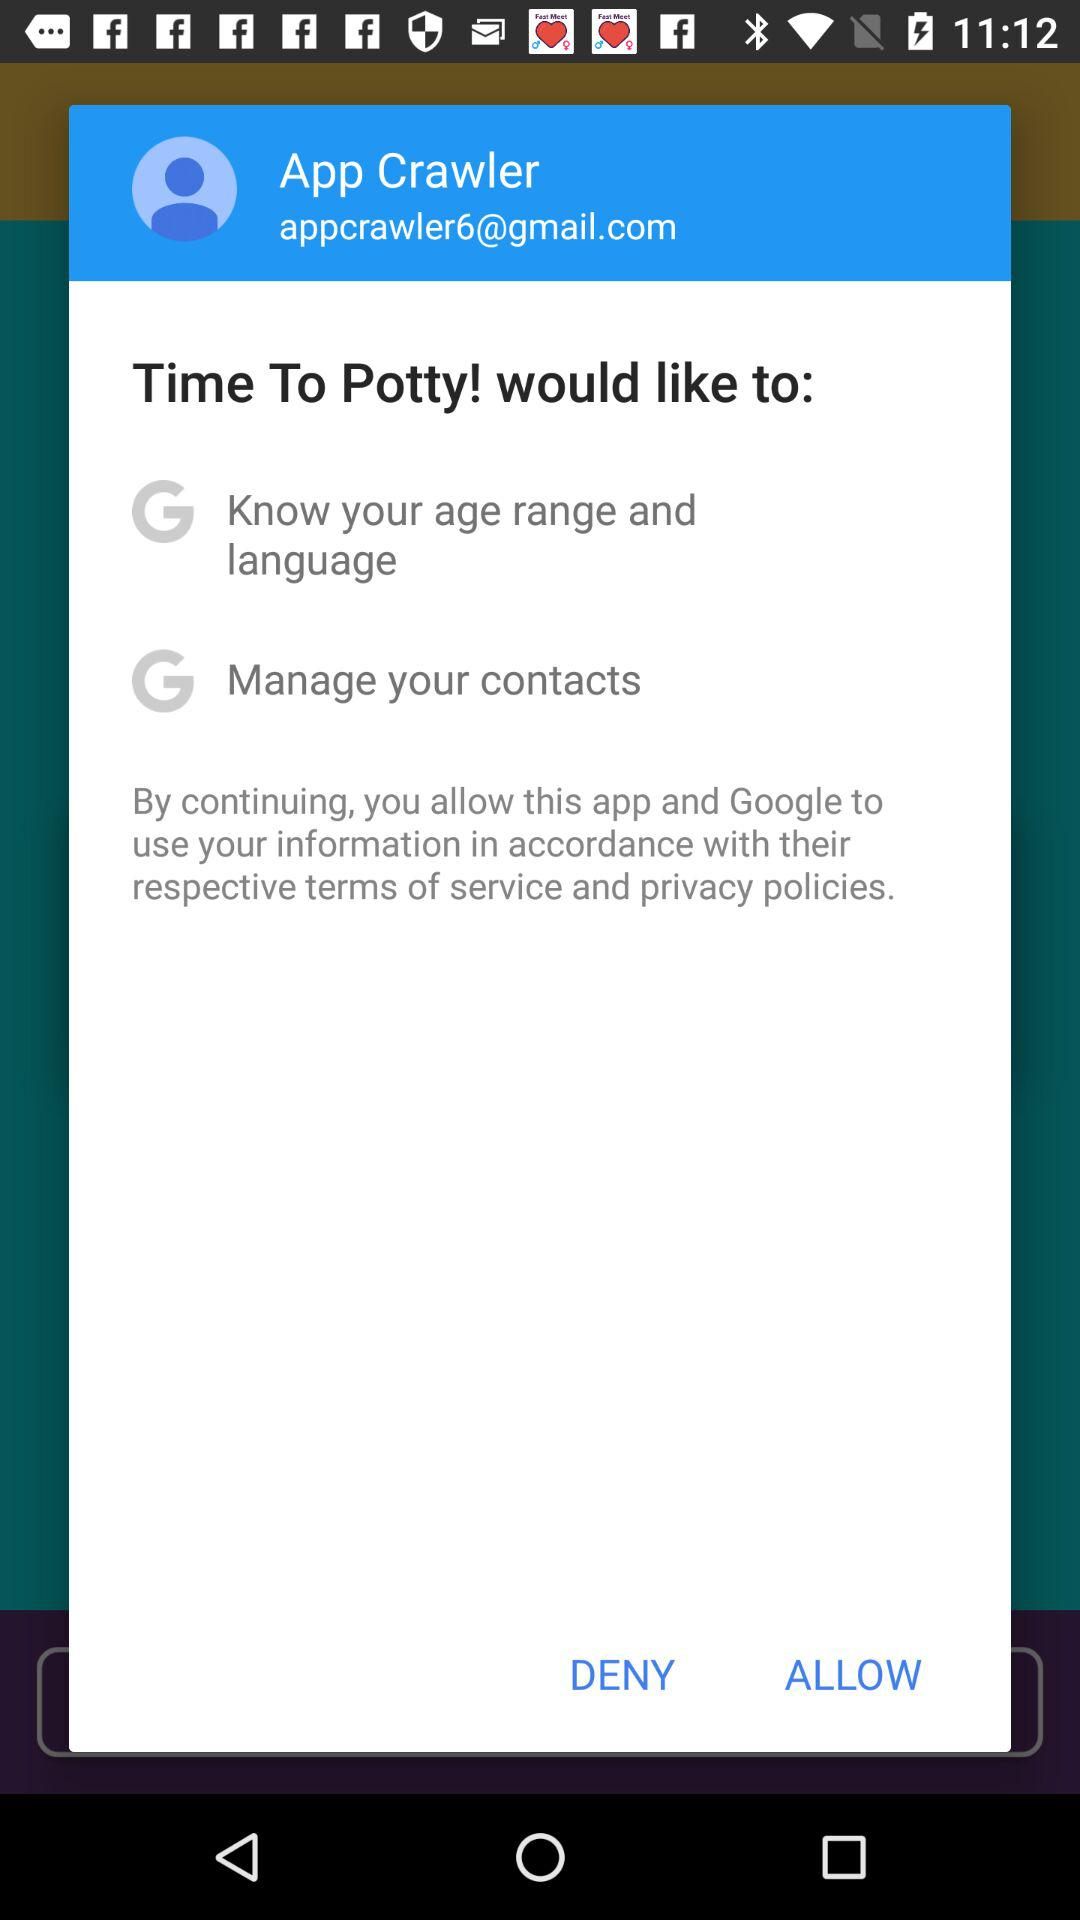How many permissions are requested by Time To Potty?
Answer the question using a single word or phrase. 2 